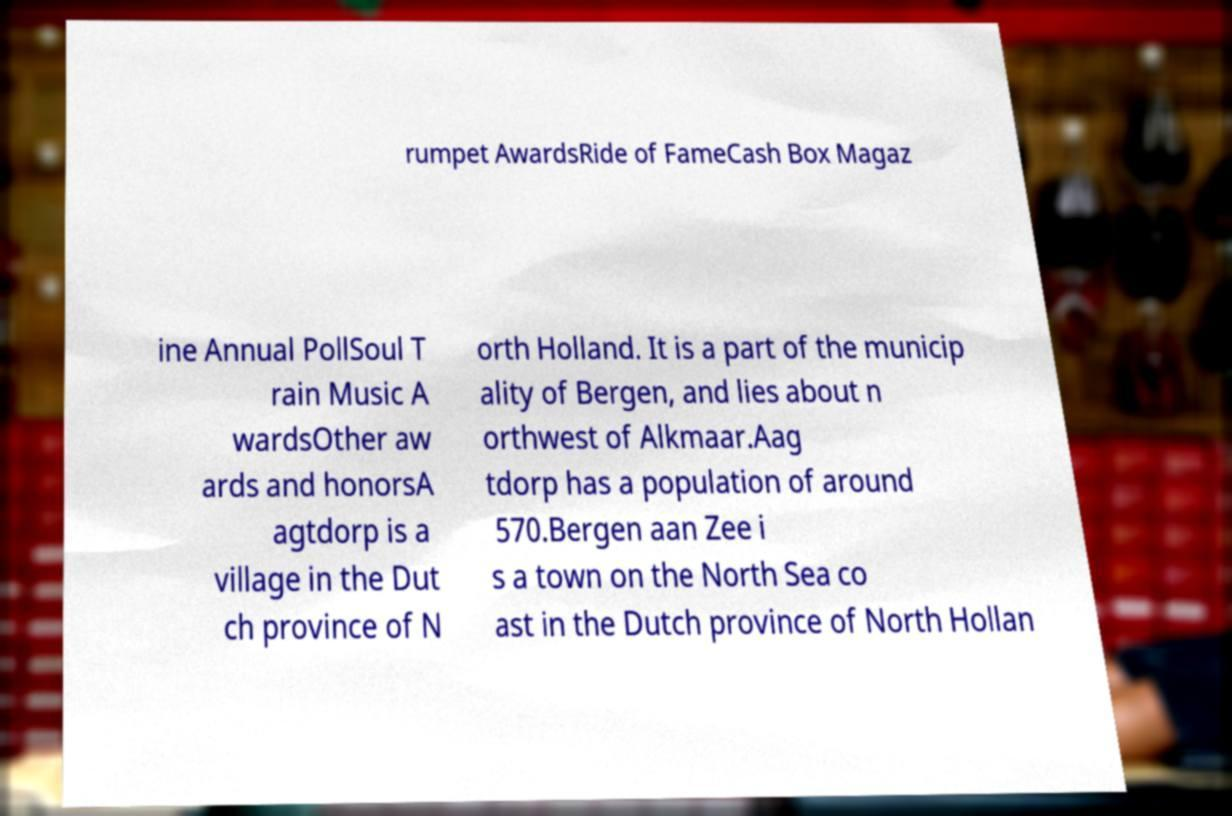Please identify and transcribe the text found in this image. rumpet AwardsRide of FameCash Box Magaz ine Annual PollSoul T rain Music A wardsOther aw ards and honorsA agtdorp is a village in the Dut ch province of N orth Holland. It is a part of the municip ality of Bergen, and lies about n orthwest of Alkmaar.Aag tdorp has a population of around 570.Bergen aan Zee i s a town on the North Sea co ast in the Dutch province of North Hollan 